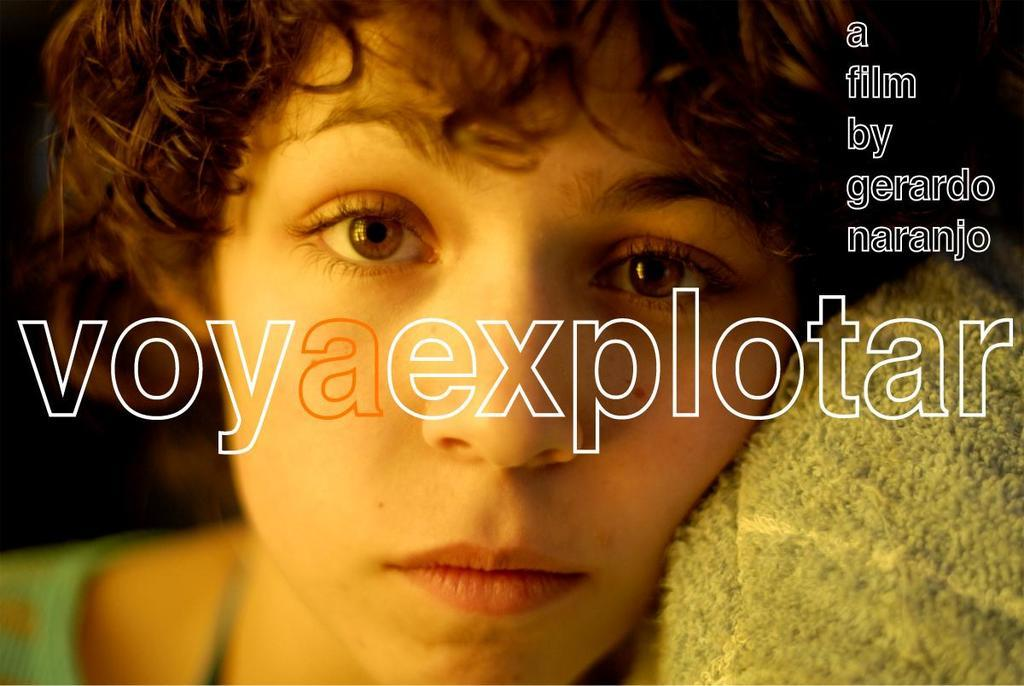What type of image is this? The image is a cover photo. Who or what is featured in the image? There is a woman in the image. Where can text be found in the image? There is text on the top right and in the middle of the image. What type of hot quartz can be seen in the image? There is no quartz, hot or otherwise, present in the image. Are there any fairies visible in the image? There are no fairies visible in the image. 